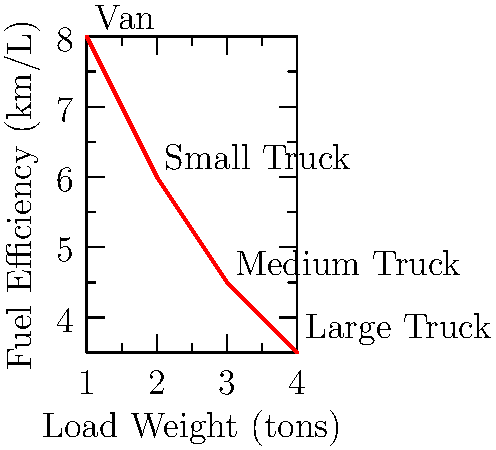As a logistics coordinator during emergency situations, you need to optimize fuel efficiency for different vehicle types. The graph shows the relationship between load weight and fuel efficiency for various vehicles. If you need to transport 6 tons of emergency supplies over a distance of 300 km, which combination of vehicles would be most fuel-efficient? Assume you can use multiple vehicles of the same type if needed. To solve this problem, we need to follow these steps:

1) First, let's calculate the fuel consumption for each vehicle type to transport 6 tons over 300 km:

   Van: Can carry 1 ton, so we need 6 vans.
   Fuel consumption = $\frac{300 \text{ km}}{8 \text{ km/L}} \times 6 = 225$ L

   Small Truck: Can carry 2 tons, so we need 3 trucks.
   Fuel consumption = $\frac{300 \text{ km}}{6 \text{ km/L}} \times 3 = 150$ L

   Medium Truck: Can carry 3 tons, so we need 2 trucks.
   Fuel consumption = $\frac{300 \text{ km}}{4.5 \text{ km/L}} \times 2 = 133.33$ L

   Large Truck: Can carry 4 tons, so we need 2 trucks (one will be partially filled).
   Fuel consumption = $\frac{300 \text{ km}}{3.5 \text{ km/L}} \times 2 = 171.43$ L

2) Compare the fuel consumption:
   The medium truck configuration uses the least amount of fuel (133.33 L).

Therefore, using two medium trucks would be the most fuel-efficient option for transporting 6 tons of emergency supplies over 300 km.
Answer: Two medium trucks 